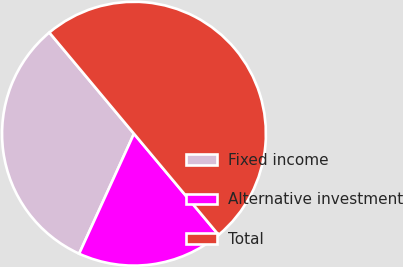Convert chart to OTSL. <chart><loc_0><loc_0><loc_500><loc_500><pie_chart><fcel>Fixed income<fcel>Alternative investment<fcel>Total<nl><fcel>32.09%<fcel>17.91%<fcel>50.0%<nl></chart> 